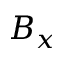<formula> <loc_0><loc_0><loc_500><loc_500>B _ { x }</formula> 